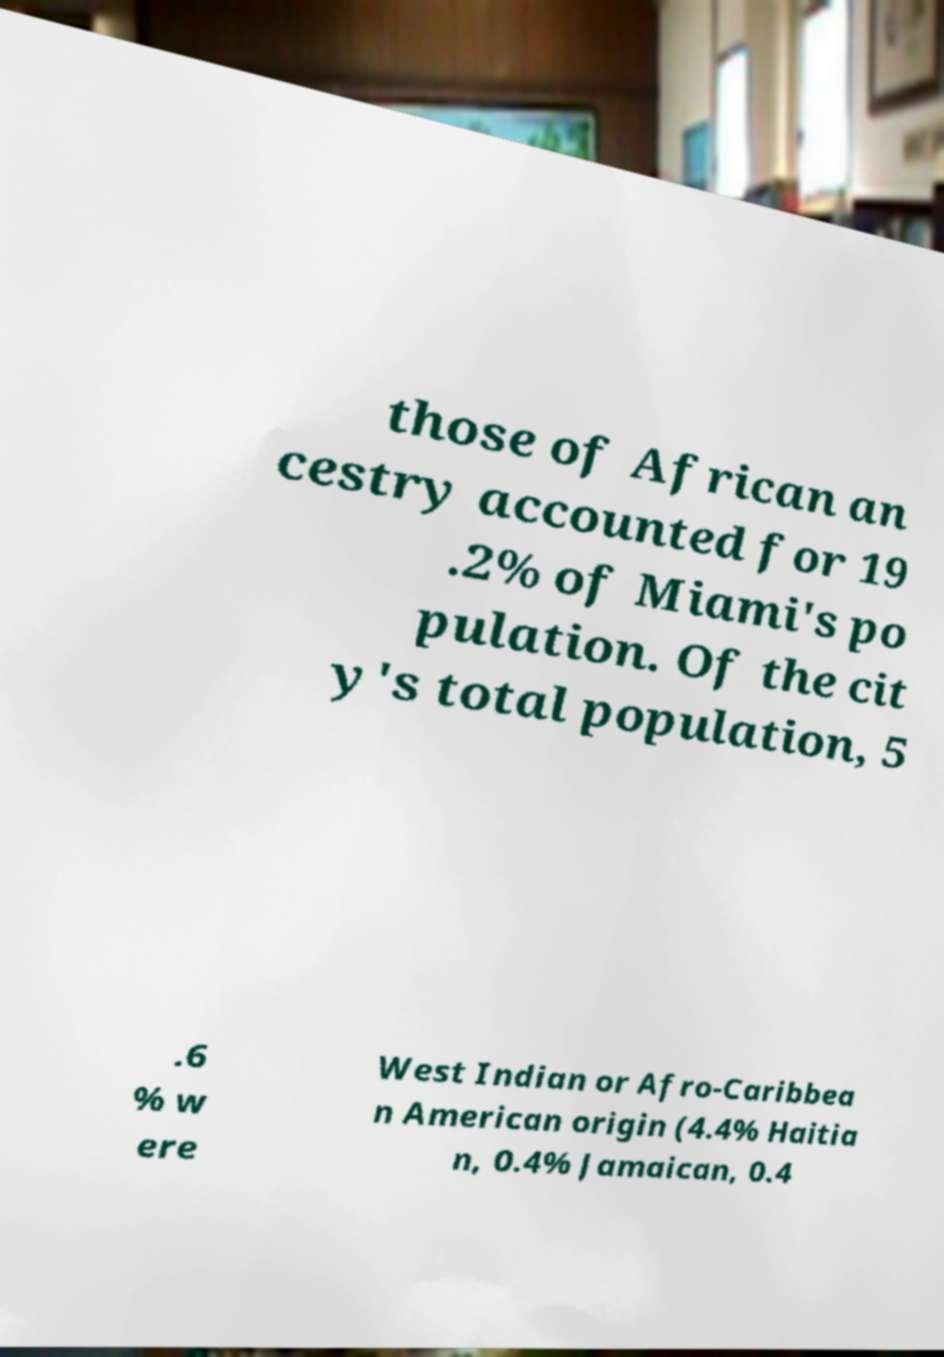Please identify and transcribe the text found in this image. those of African an cestry accounted for 19 .2% of Miami's po pulation. Of the cit y's total population, 5 .6 % w ere West Indian or Afro-Caribbea n American origin (4.4% Haitia n, 0.4% Jamaican, 0.4 